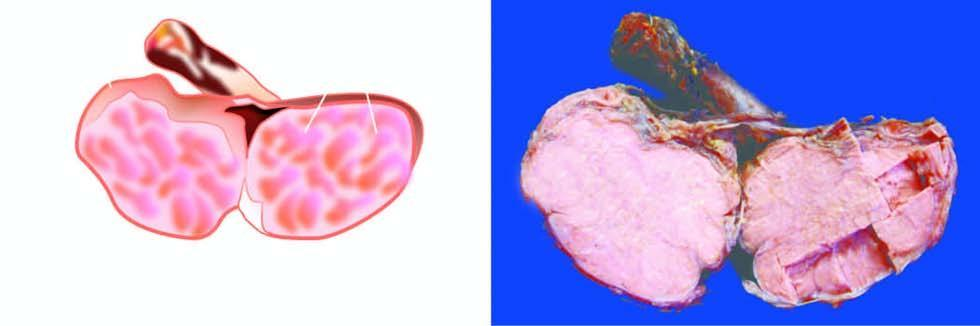does sectioned surface show replacement of the entire testis by lobulated, homogeneous, grey-white mass?
Answer the question using a single word or phrase. Yes 